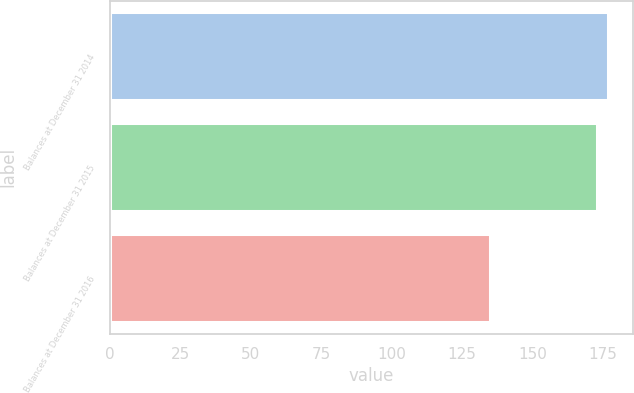<chart> <loc_0><loc_0><loc_500><loc_500><bar_chart><fcel>Balances at December 31 2014<fcel>Balances at December 31 2015<fcel>Balances at December 31 2016<nl><fcel>176.9<fcel>173<fcel>135<nl></chart> 